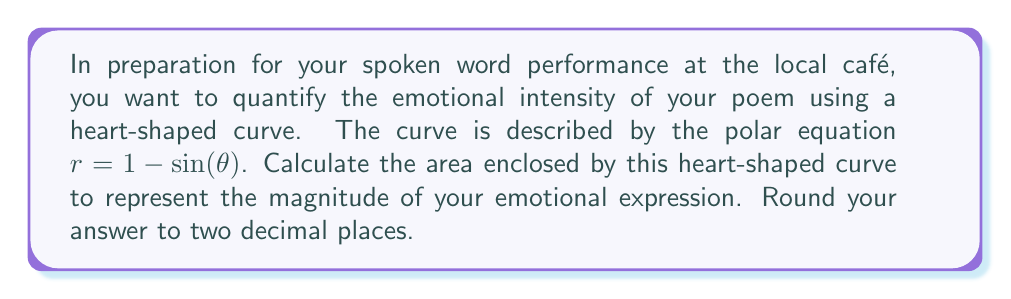Help me with this question. Let's approach this step-by-step:

1) The general formula for the area enclosed by a polar curve is:

   $$A = \frac{1}{2} \int_{0}^{2\pi} r^2 d\theta$$

2) Our curve is given by $r = 1 - \sin(\theta)$. We need to square this:

   $$r^2 = (1 - \sin(\theta))^2 = 1 - 2\sin(\theta) + \sin^2(\theta)$$

3) Now we can set up our integral:

   $$A = \frac{1}{2} \int_{0}^{2\pi} (1 - 2\sin(\theta) + \sin^2(\theta)) d\theta$$

4) Let's integrate each term separately:

   $$\begin{align}
   A &= \frac{1}{2} \left[ \int_{0}^{2\pi} 1 d\theta - \int_{0}^{2\pi} 2\sin(\theta) d\theta + \int_{0}^{2\pi} \sin^2(\theta) d\theta \right] \\
   &= \frac{1}{2} \left[ \theta - 2(-\cos(\theta)) + \frac{\theta}{2} - \frac{\sin(2\theta)}{4} \right]_{0}^{2\pi}
   \end{align}$$

5) Evaluate the integral:

   $$\begin{align}
   A &= \frac{1}{2} \left[ (2\pi - 0) - 2(-\cos(2\pi) + \cos(0)) + (\pi - 0) - (\frac{\sin(4\pi)}{4} - \frac{\sin(0)}{4}) \right] \\
   &= \frac{1}{2} [2\pi - 0 + \pi] \\
   &= \frac{3\pi}{2}
   \end{align}$$

6) The final step is to round to two decimal places:

   $$A \approx 4.71$$

[asy]
import graph;
size(200);
real r(real t) {return 1-sin(t);}
path heart = scale(100) * graph(r,0,2pi,operator ..);
fill(heart,red);
draw(heart,red);
[/asy]
Answer: $4.71$ square units 